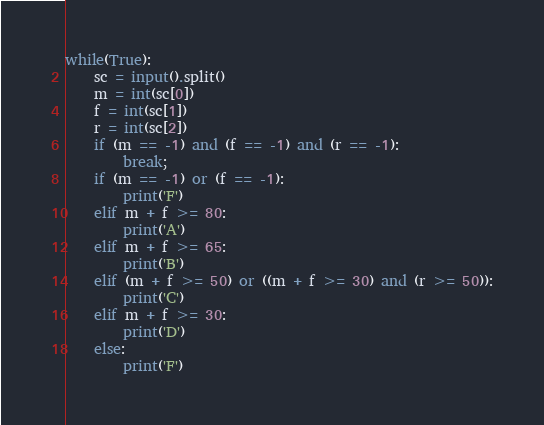Convert code to text. <code><loc_0><loc_0><loc_500><loc_500><_Python_>while(True):
    sc = input().split()
    m = int(sc[0])
    f = int(sc[1])
    r = int(sc[2])
    if (m == -1) and (f == -1) and (r == -1):
        break;
    if (m == -1) or (f == -1):
        print('F')
    elif m + f >= 80:
        print('A')
    elif m + f >= 65:
        print('B')
    elif (m + f >= 50) or ((m + f >= 30) and (r >= 50)):
        print('C')
    elif m + f >= 30:
        print('D')
    else:
        print('F')
</code> 